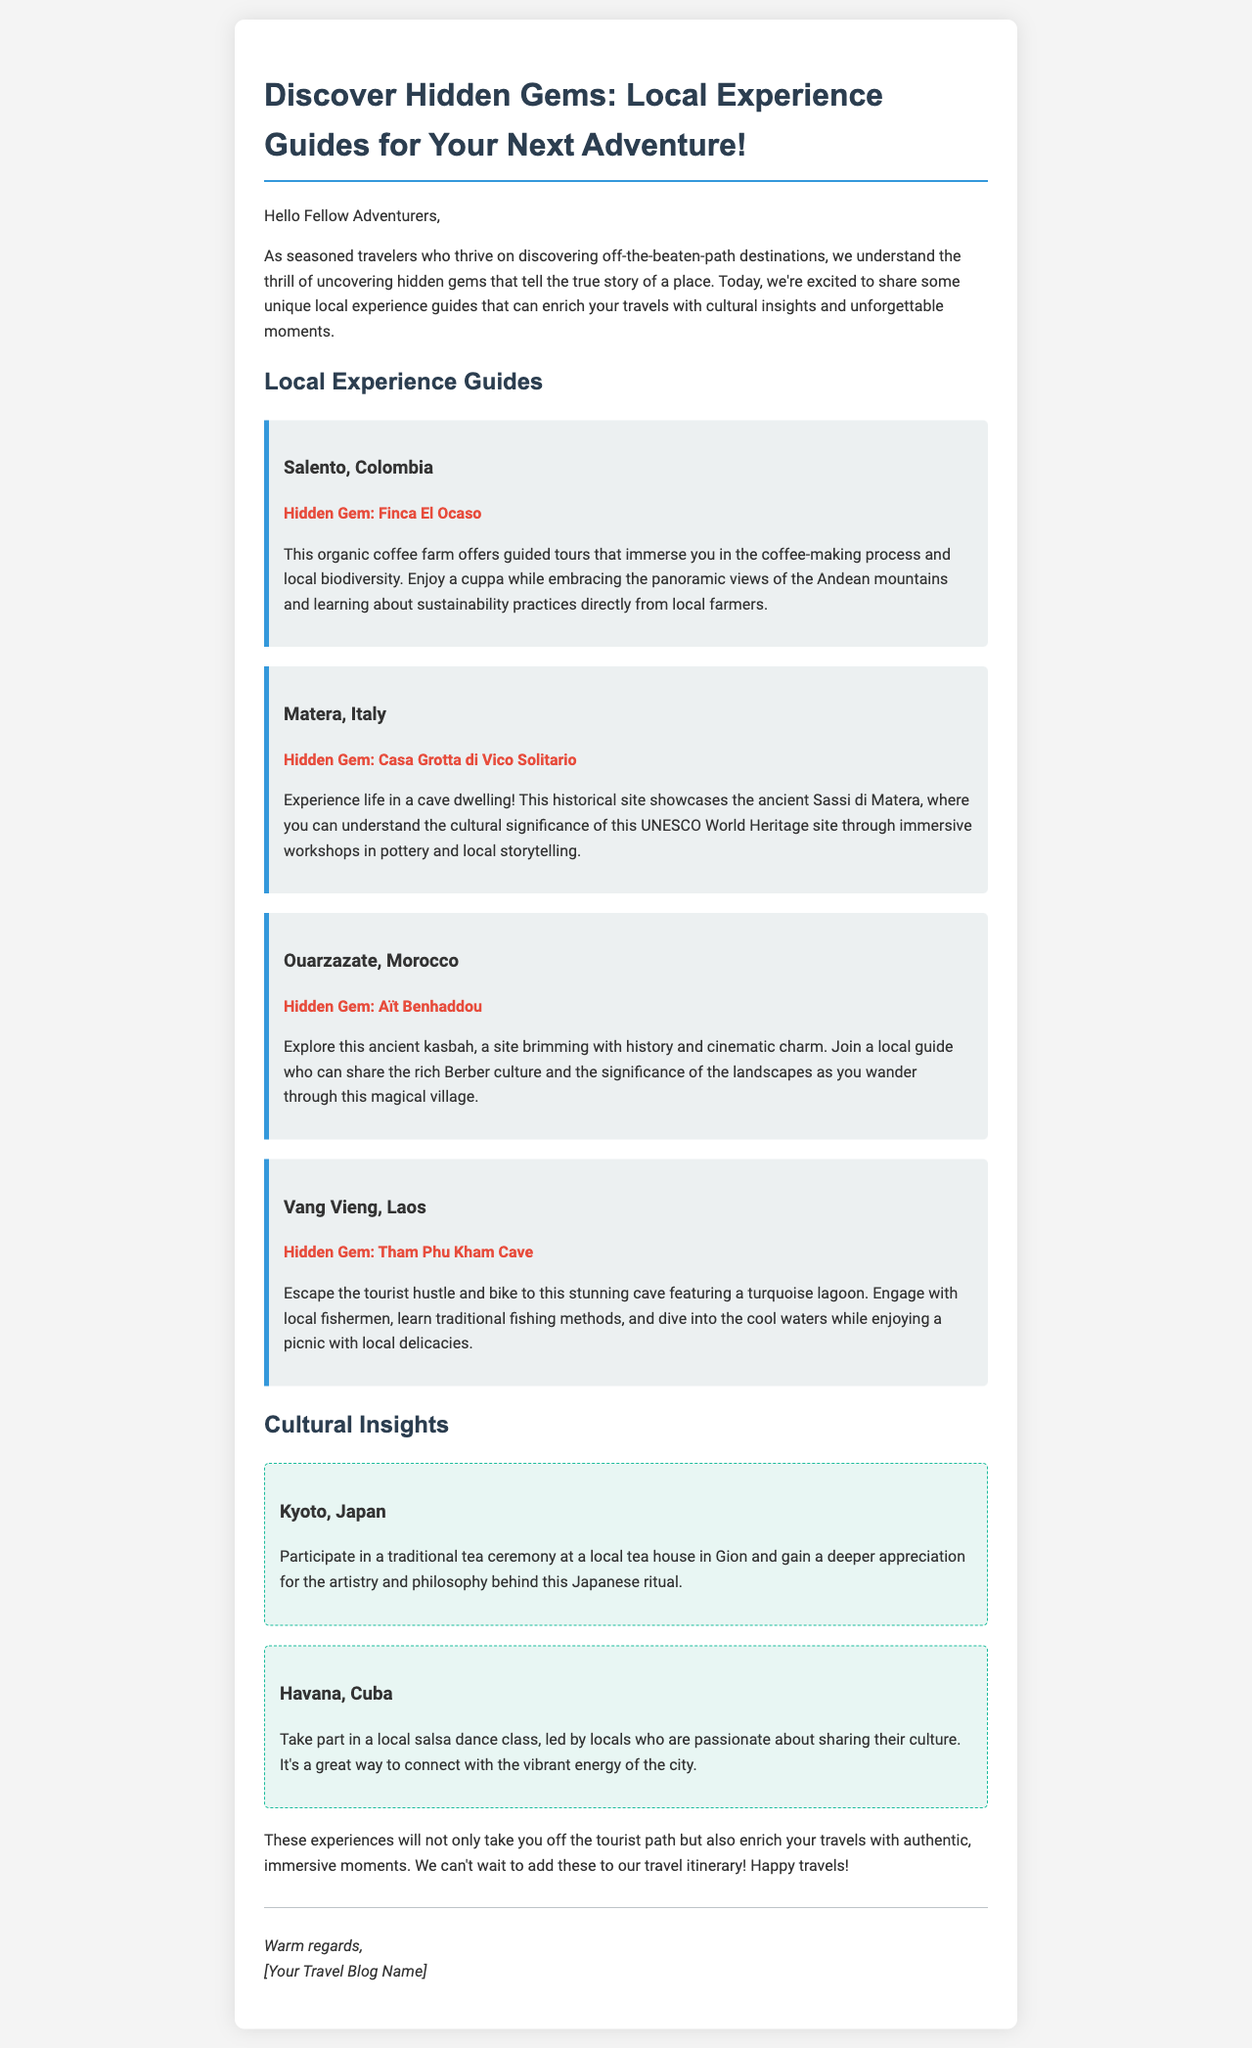What is the title of the email? The title of the email is located in the document's head section, which indicates the main topic of the email.
Answer: Discover Hidden Gems: Local Experience Guides for Your Next Adventure! What is the hidden gem in Salento, Colombia? The hidden gem is specifically mentioned under the Salento section in the email.
Answer: Finca El Ocaso Which country is associated with the hidden gem Aït Benhaddou? The document explicitly mentions the location of Aït Benhaddou within its description.
Answer: Morocco How many cultural insights are provided in the email? The count of distinct cultural insight sections in the email gives the answer.
Answer: 2 What local experience can you participate in Kyoto, Japan? The document details specific cultural activities available in various destinations, including Kyoto.
Answer: traditional tea ceremony What type of workshop is available in Casa Grotta di Vico Solitario? The email describes the type of immersive experiences available in the Matera section.
Answer: pottery Which destination includes a turquoise lagoon? The document elaborates on the features of various destinations, including the cave with a lagoon.
Answer: Vang Vieng, Laos What kind of class can you take in Havana, Cuba? The email discusses a specific activity that highlights the local culture in Havana.
Answer: salsa dance class What is the primary purpose of the email? The email's introduction clarifies the intent behind sharing the local experience guides with readers.
Answer: To share local experience guides 